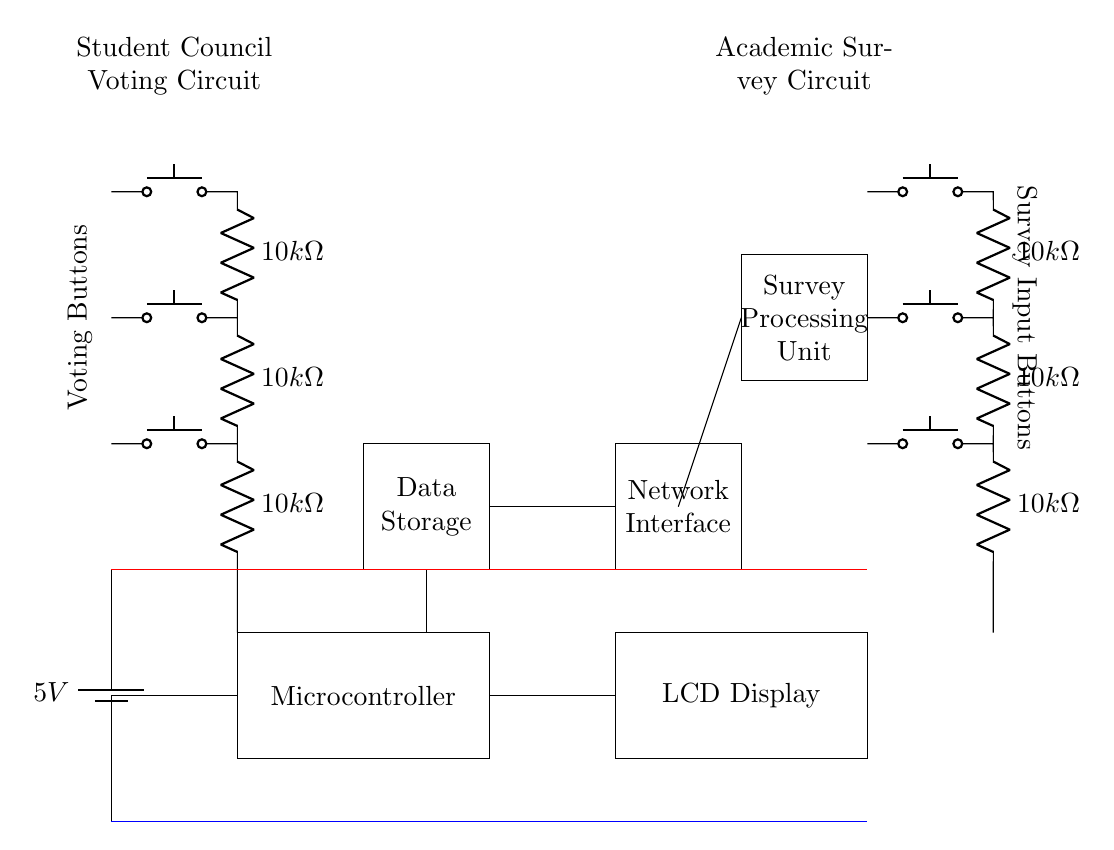What is the main power supply voltage of the circuit? The power supply voltage is indicated as 5V on the battery symbol in the circuit.
Answer: 5V What components are used for the voting input? The voting input is represented by three push buttons, each leading to a resistor of 10k ohms.
Answer: Push buttons and resistors How many voting buttons are present in this circuit? There are three push buttons integrated for the voting process, as shown in the diagram.
Answer: Three What type of display is used in the circuit? An LCD Display is indicated in the circuit diagram, which is utilized for displaying information.
Answer: LCD Display What is the function of the microcontroller? The microcontroller serves as the central processing unit that coordinates inputs and manages the voting process.
Answer: Central processing unit Where does the survey input connect in the circuit? The survey input connects to a set of three push buttons leading through resistors, similar to the voting inputs.
Answer: To push buttons and resistors What is the purpose of the network interface component? The network interface facilitates communication with external networks, likely for data transmission related to the election or survey.
Answer: Communication with external networks 